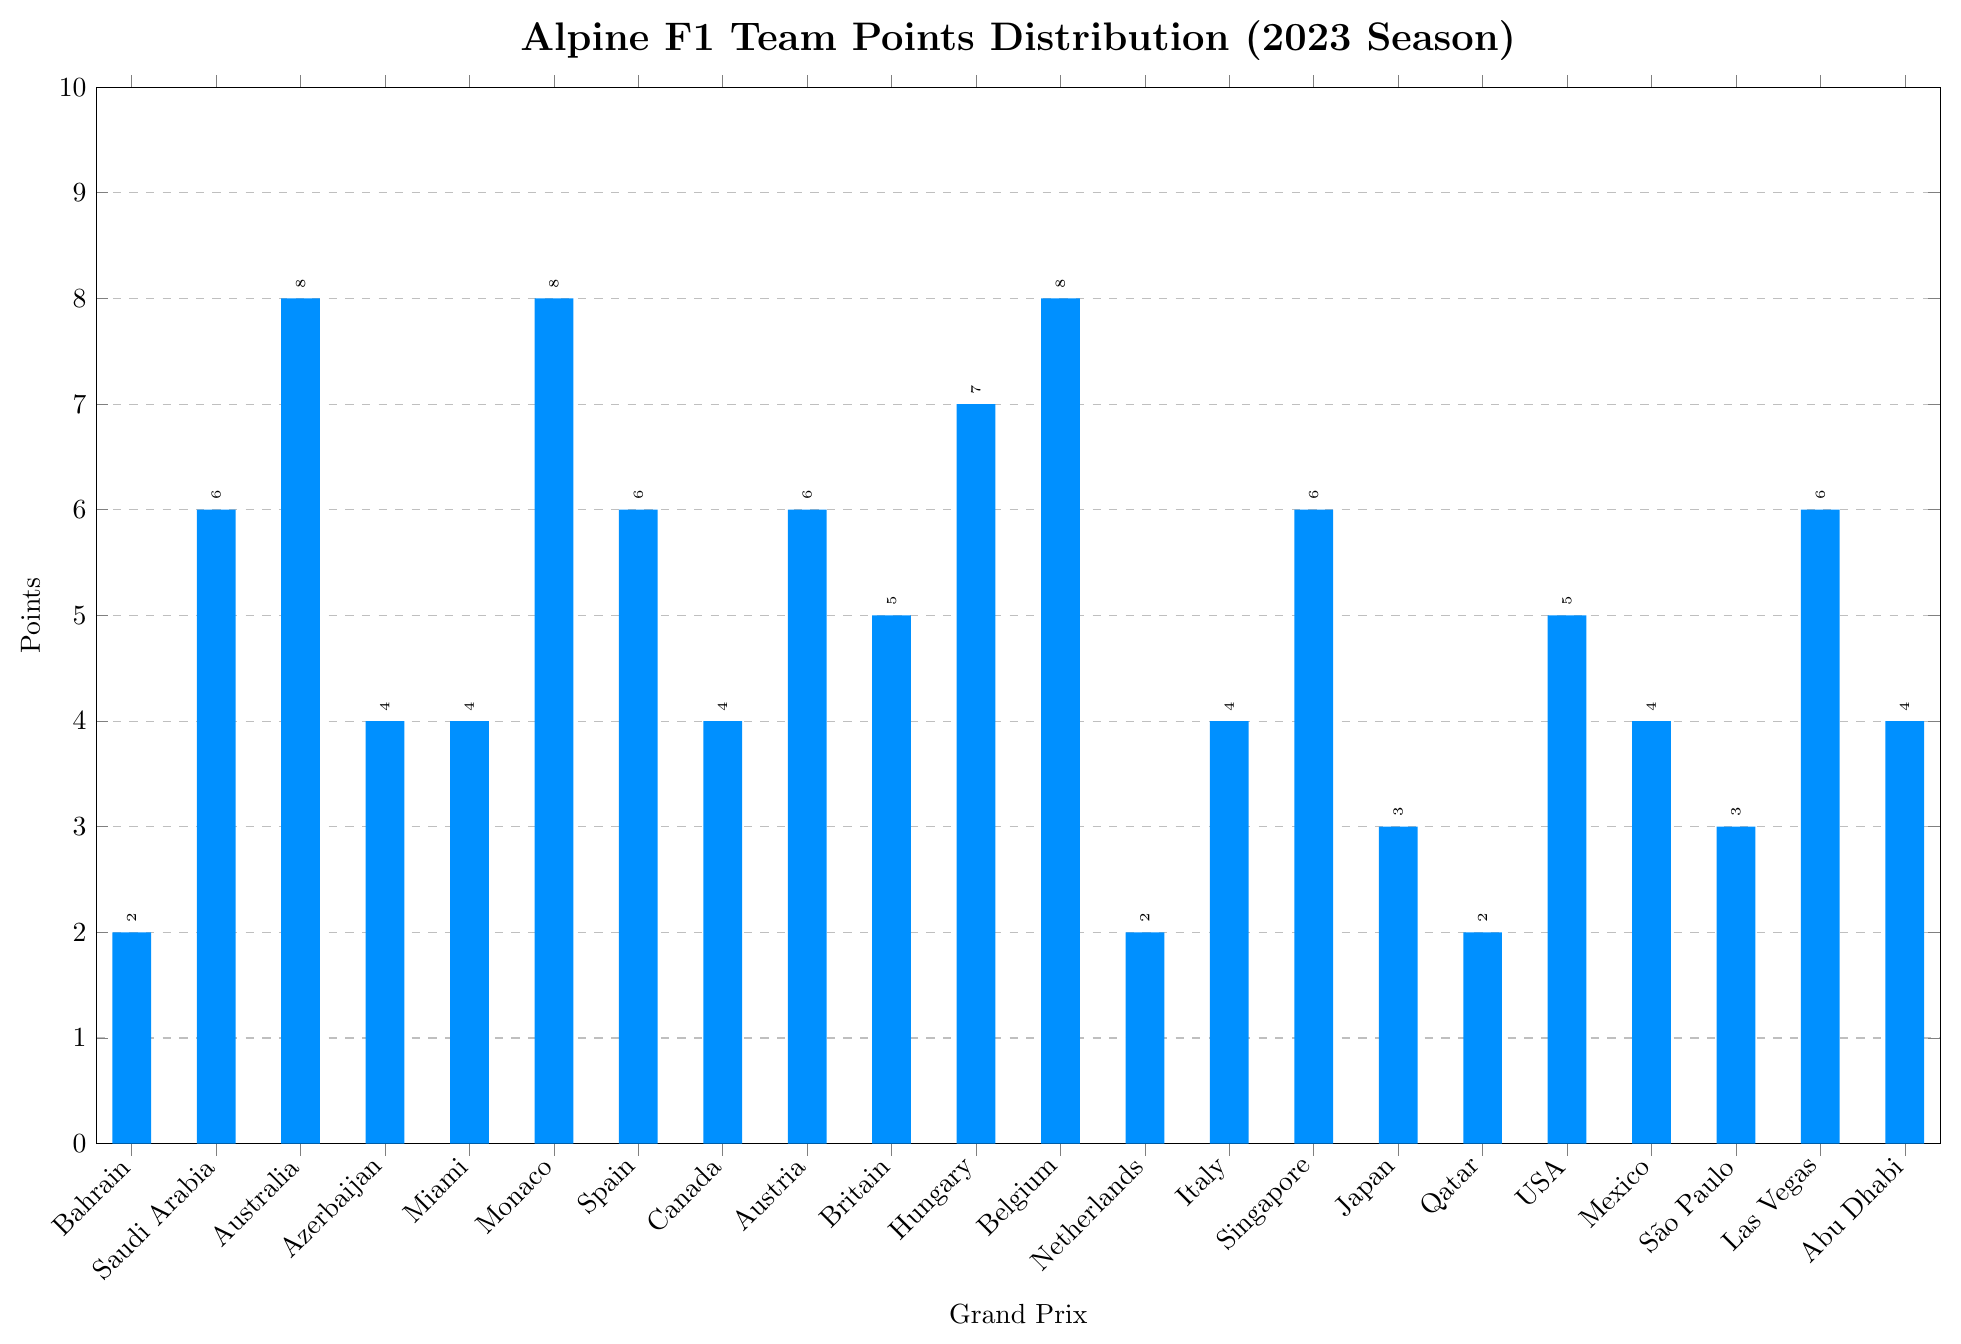What is the highest number of points that Alpine F1 Team scored in a single race? By observing the bar chart, the highest point is determined by the tallest bar. Identify the race with the highest bar and read the corresponding value.
Answer: 8 How many races did Alpine F1 Team score exactly 6 points? Identify the bars with a height corresponding to 6 points and count them.
Answer: 5 Which Grand Prix races have the lowest points scored by Alpine F1 Team? Find the bars with the lowest height (2 points) and list the corresponding Grand Prix names.
Answer: Bahrain, Dutch, Qatar What is the total number of points scored by Alpine F1 Team in the first three Grand Prix races? Sum up the points for Bahrain, Saudi Arabian, and Australian Grand Prix by adding the heights of the respective bars (2+6+8).
Answer: 16 Describe the distribution of points for Monaco and Belgium Grand Prix. Identify and compare the height of the bars for Monaco and Belgium Grand Prix.
Answer: Both scored 8 points each Which race has more points: British Grand Prix or United States Grand Prix? Compare the heights of the bars for British and United States Grand Prix to see which is taller.
Answer: British Grand Prix By how much did the points in Hungarian Grand Prix exceed the points in São Paulo Grand Prix? Subtract the height of the São Paulo bar from that of the Hungarian bar (7-3).
Answer: 4 What is the average number of points scored across all races? Sum all the points and divide by the total number of races (sum of points = 99, number of races = 22, average = 99/22).
Answer: 4.5 How many times did Alpine F1 Team score at least 7 points in a race? Count the bars with heights of 7 or more points.
Answer: 4 Is there a consistent pattern in the points distribution throughout the season? Observe the fluctuation in bar heights throughout the season and consider whether there is a discernible trend.
Answer: No consistent pattern 